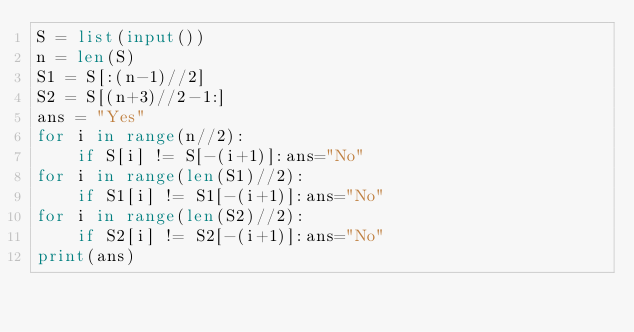<code> <loc_0><loc_0><loc_500><loc_500><_Python_>S = list(input())
n = len(S)
S1 = S[:(n-1)//2]
S2 = S[(n+3)//2-1:]
ans = "Yes"
for i in range(n//2):
	if S[i] != S[-(i+1)]:ans="No"
for i in range(len(S1)//2):
	if S1[i] != S1[-(i+1)]:ans="No"
for i in range(len(S2)//2):
	if S2[i] != S2[-(i+1)]:ans="No"
print(ans)</code> 